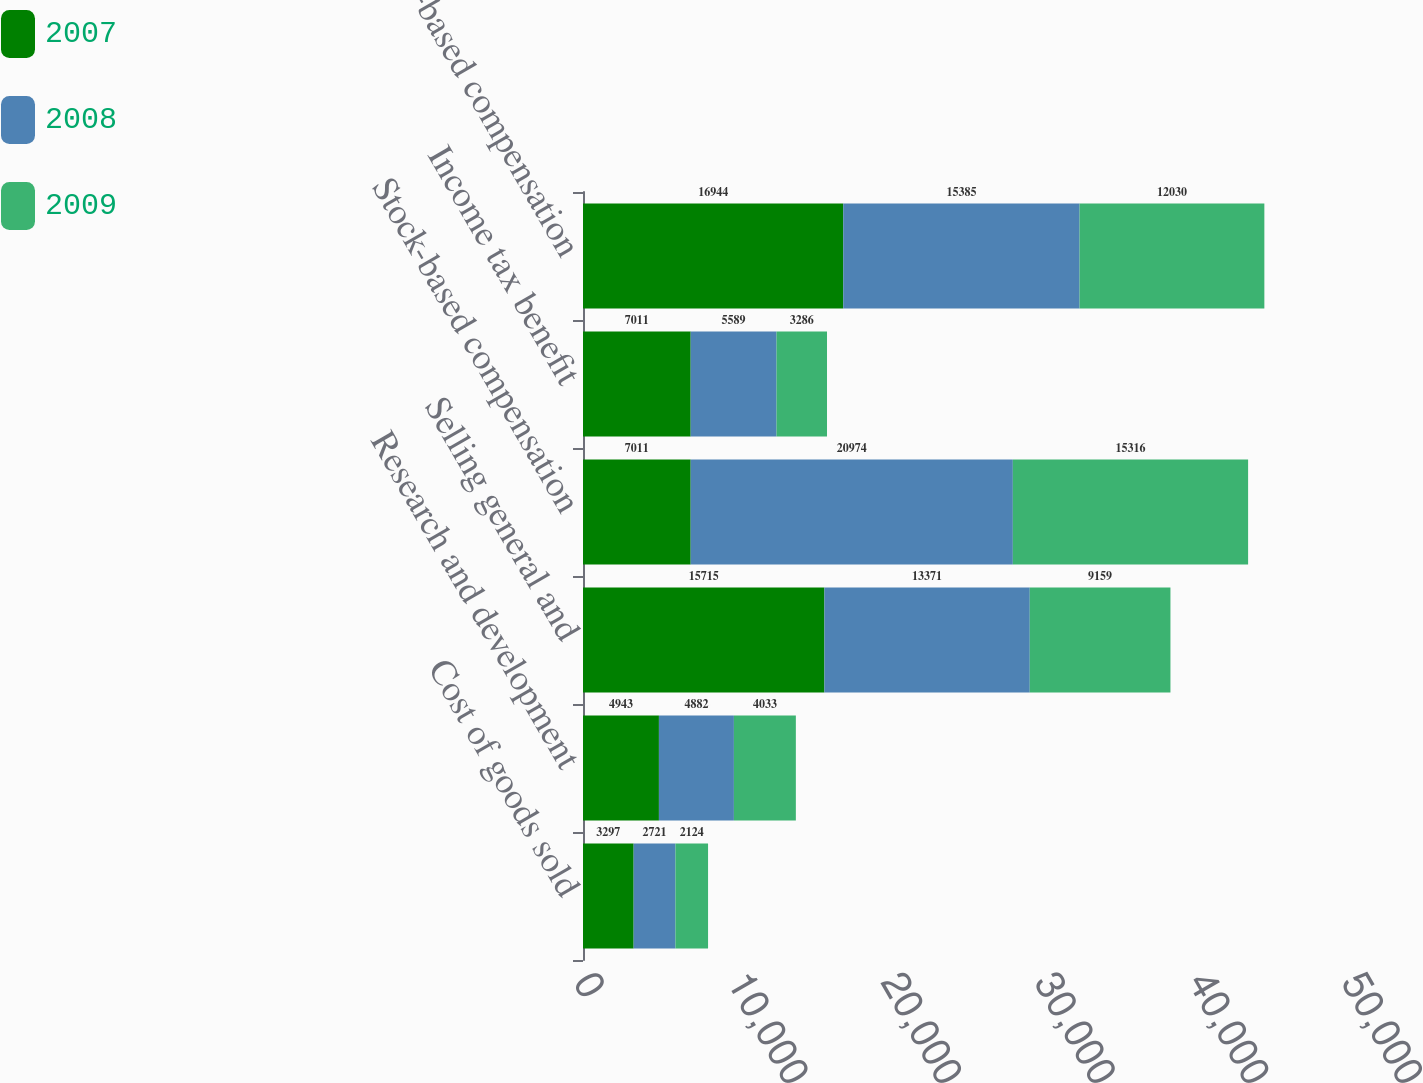<chart> <loc_0><loc_0><loc_500><loc_500><stacked_bar_chart><ecel><fcel>Cost of goods sold<fcel>Research and development<fcel>Selling general and<fcel>Stock-based compensation<fcel>Income tax benefit<fcel>Total stock-based compensation<nl><fcel>2007<fcel>3297<fcel>4943<fcel>15715<fcel>7011<fcel>7011<fcel>16944<nl><fcel>2008<fcel>2721<fcel>4882<fcel>13371<fcel>20974<fcel>5589<fcel>15385<nl><fcel>2009<fcel>2124<fcel>4033<fcel>9159<fcel>15316<fcel>3286<fcel>12030<nl></chart> 